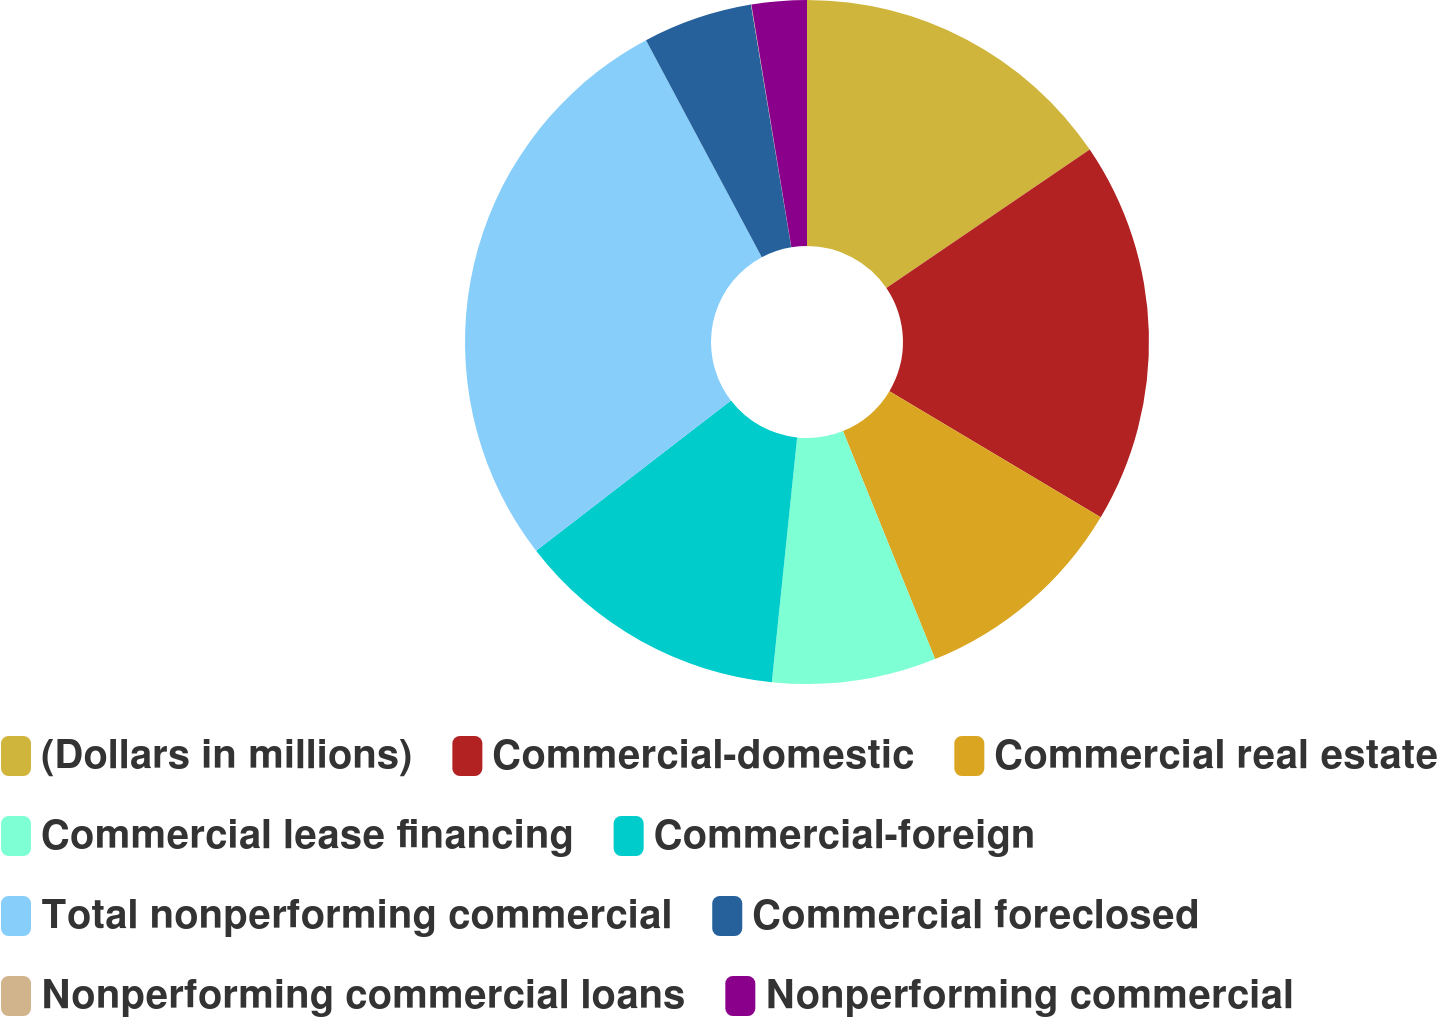<chart> <loc_0><loc_0><loc_500><loc_500><pie_chart><fcel>(Dollars in millions)<fcel>Commercial-domestic<fcel>Commercial real estate<fcel>Commercial lease financing<fcel>Commercial-foreign<fcel>Total nonperforming commercial<fcel>Commercial foreclosed<fcel>Nonperforming commercial loans<fcel>Nonperforming commercial<nl><fcel>15.49%<fcel>18.07%<fcel>10.33%<fcel>7.75%<fcel>12.91%<fcel>27.65%<fcel>5.18%<fcel>0.02%<fcel>2.6%<nl></chart> 